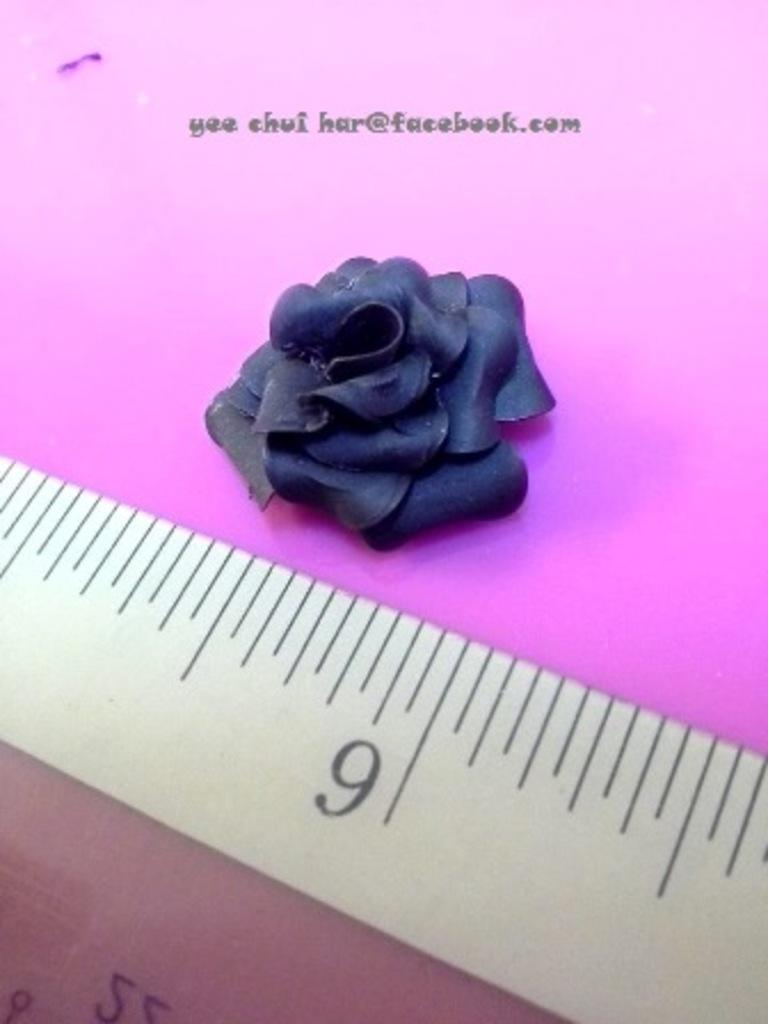<image>
Render a clear and concise summary of the photo. An email address, yee chui har@facebook.com is printed on purple paper. 